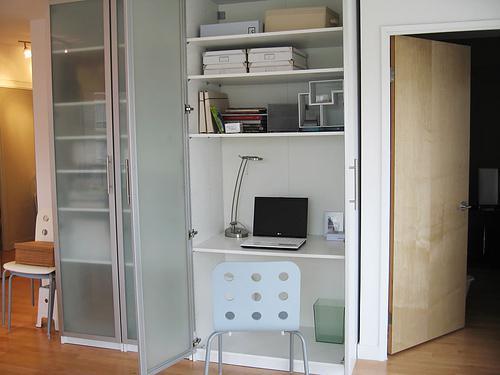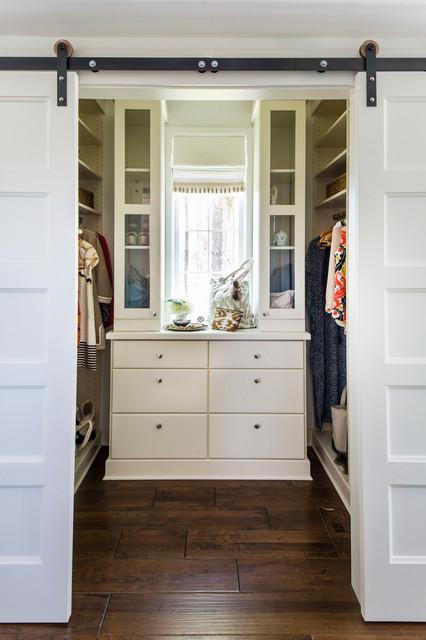The first image is the image on the left, the second image is the image on the right. Evaluate the accuracy of this statement regarding the images: "There is a white chair shown in one of the images.". Is it true? Answer yes or no. Yes. The first image is the image on the left, the second image is the image on the right. For the images displayed, is the sentence "There is a bed in the image on the right." factually correct? Answer yes or no. No. 